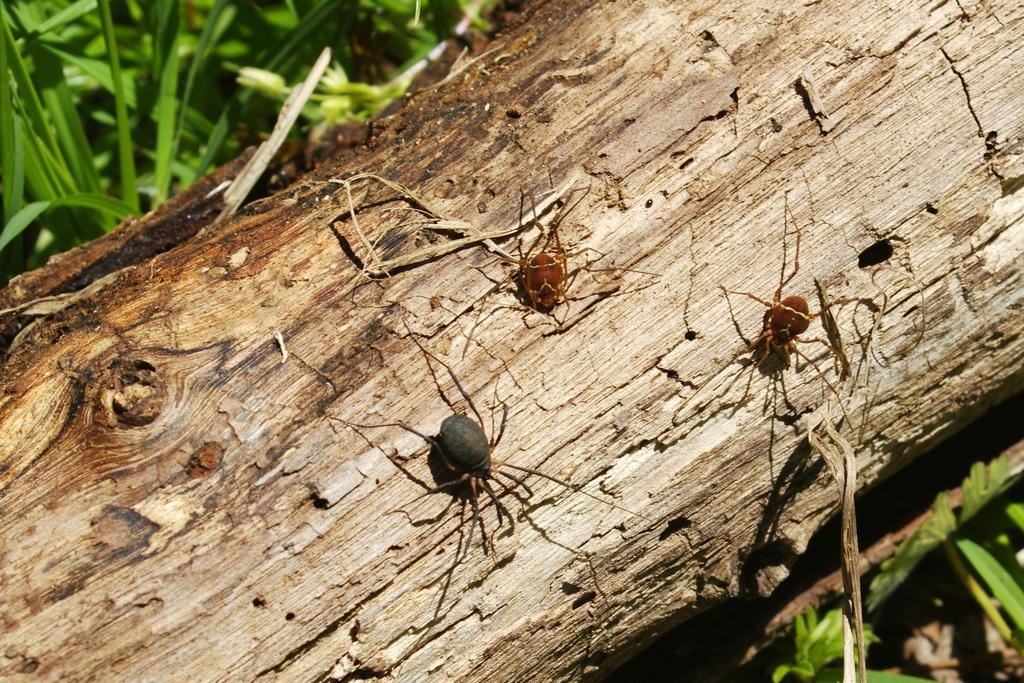What is the wooden object that the insects are on in the image? The provided facts do not specify the type of wooden object, so we cannot determine its exact nature. What type of vegetation is visible in the image? Grass is visible in both the top left and bottom right corners of the image. Can you describe the insects in the image? The provided facts do not describe the insects in detail, so we cannot provide a description of them. What route does the duck take to cross the wooden object in the image? There is no duck present in the image, so we cannot determine a route for it to cross the wooden object. 